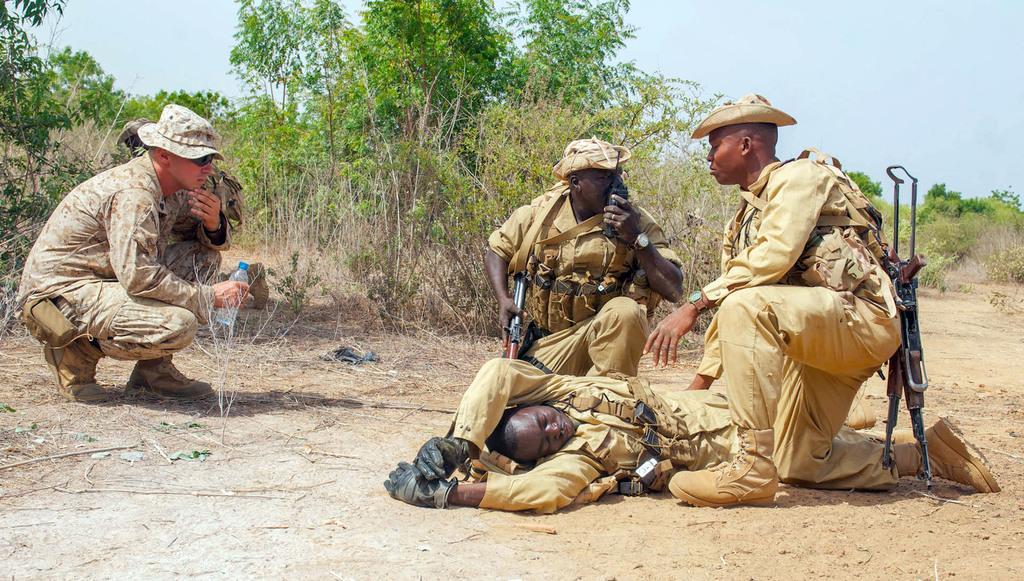In one or two sentences, can you explain what this image depicts? In this picture I can observe four members. Three of them are wearing hats on their heads. Two of them are holding guns. In the background there are some plants. I can observe a sky. 